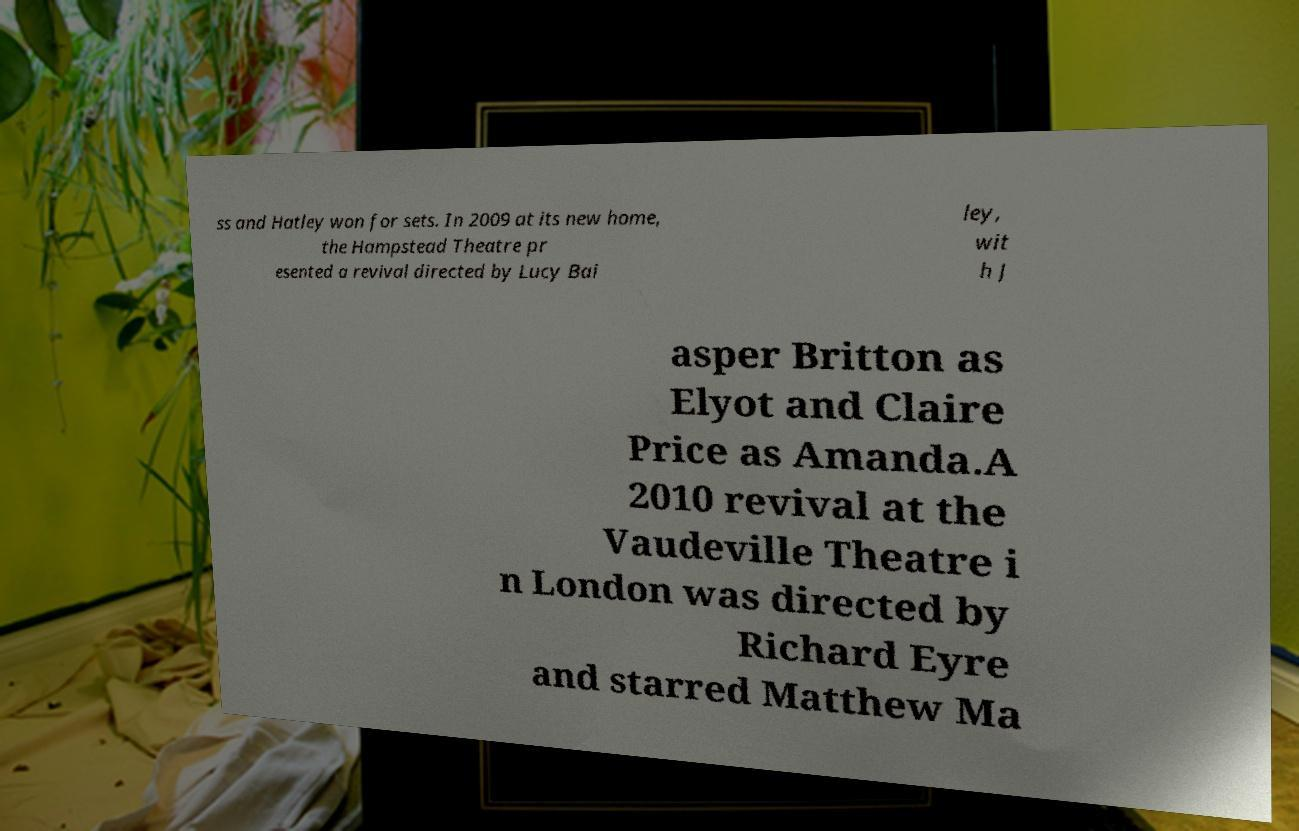Could you assist in decoding the text presented in this image and type it out clearly? ss and Hatley won for sets. In 2009 at its new home, the Hampstead Theatre pr esented a revival directed by Lucy Bai ley, wit h J asper Britton as Elyot and Claire Price as Amanda.A 2010 revival at the Vaudeville Theatre i n London was directed by Richard Eyre and starred Matthew Ma 